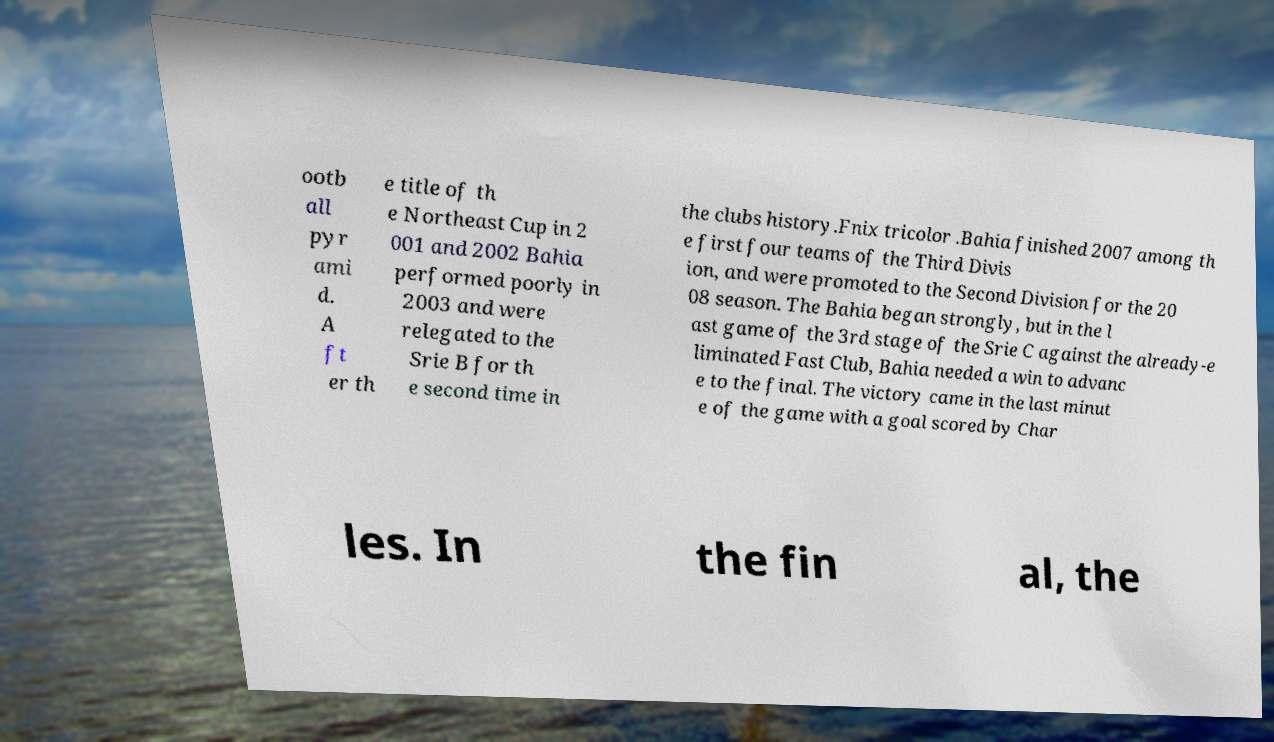Could you extract and type out the text from this image? ootb all pyr ami d. A ft er th e title of th e Northeast Cup in 2 001 and 2002 Bahia performed poorly in 2003 and were relegated to the Srie B for th e second time in the clubs history.Fnix tricolor .Bahia finished 2007 among th e first four teams of the Third Divis ion, and were promoted to the Second Division for the 20 08 season. The Bahia began strongly, but in the l ast game of the 3rd stage of the Srie C against the already-e liminated Fast Club, Bahia needed a win to advanc e to the final. The victory came in the last minut e of the game with a goal scored by Char les. In the fin al, the 